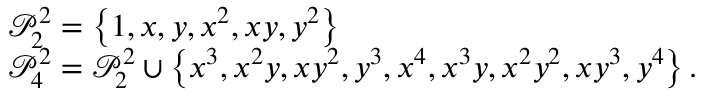<formula> <loc_0><loc_0><loc_500><loc_500>\begin{array} { r l } & { \mathcal { P } _ { 2 } ^ { 2 } = \left \{ 1 , x , y , x ^ { 2 } , x y , y ^ { 2 } \right \} } \\ & { \mathcal { P } _ { 4 } ^ { 2 } = \mathcal { P } _ { 2 } ^ { 2 } \cup \left \{ x ^ { 3 } , x ^ { 2 } y , x y ^ { 2 } , y ^ { 3 } , x ^ { 4 } , x ^ { 3 } y , x ^ { 2 } y ^ { 2 } , x y ^ { 3 } , y ^ { 4 } \right \} . } \end{array}</formula> 